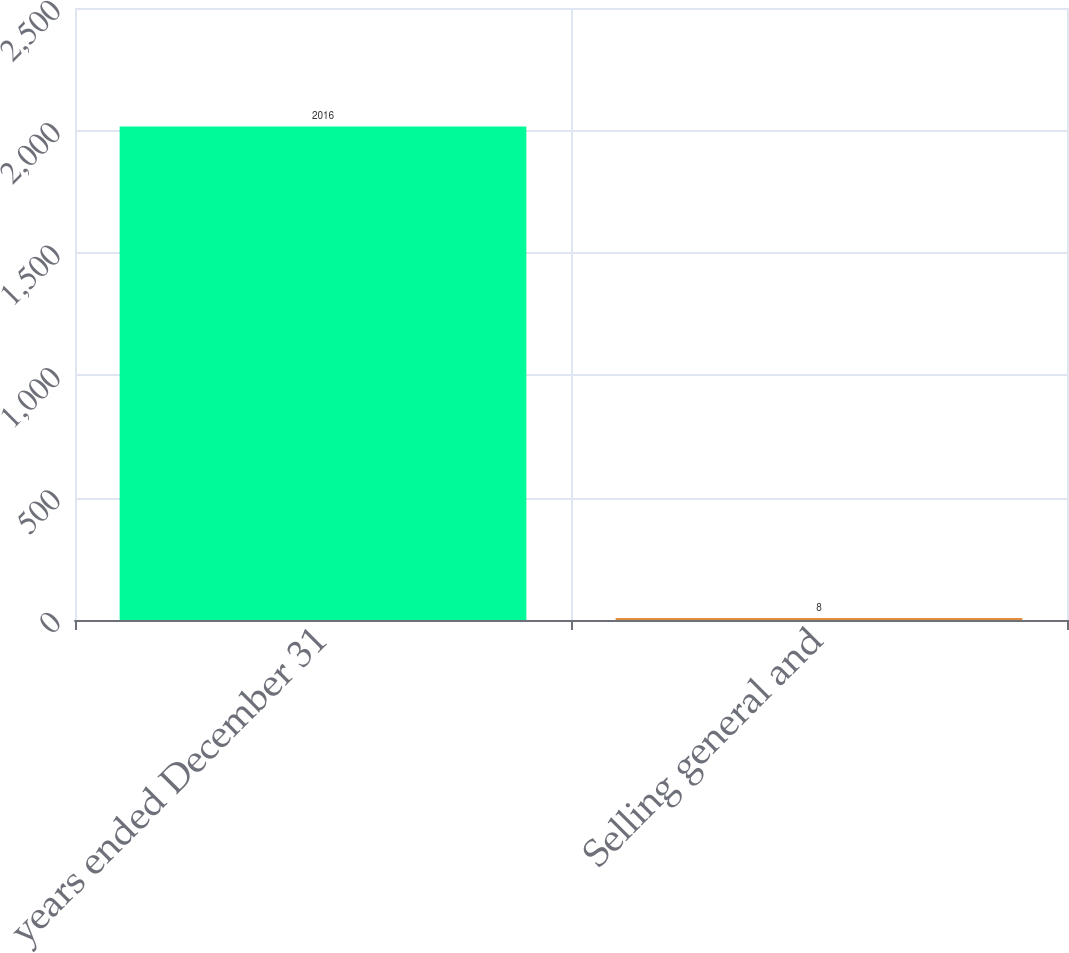Convert chart. <chart><loc_0><loc_0><loc_500><loc_500><bar_chart><fcel>years ended December 31<fcel>Selling general and<nl><fcel>2016<fcel>8<nl></chart> 